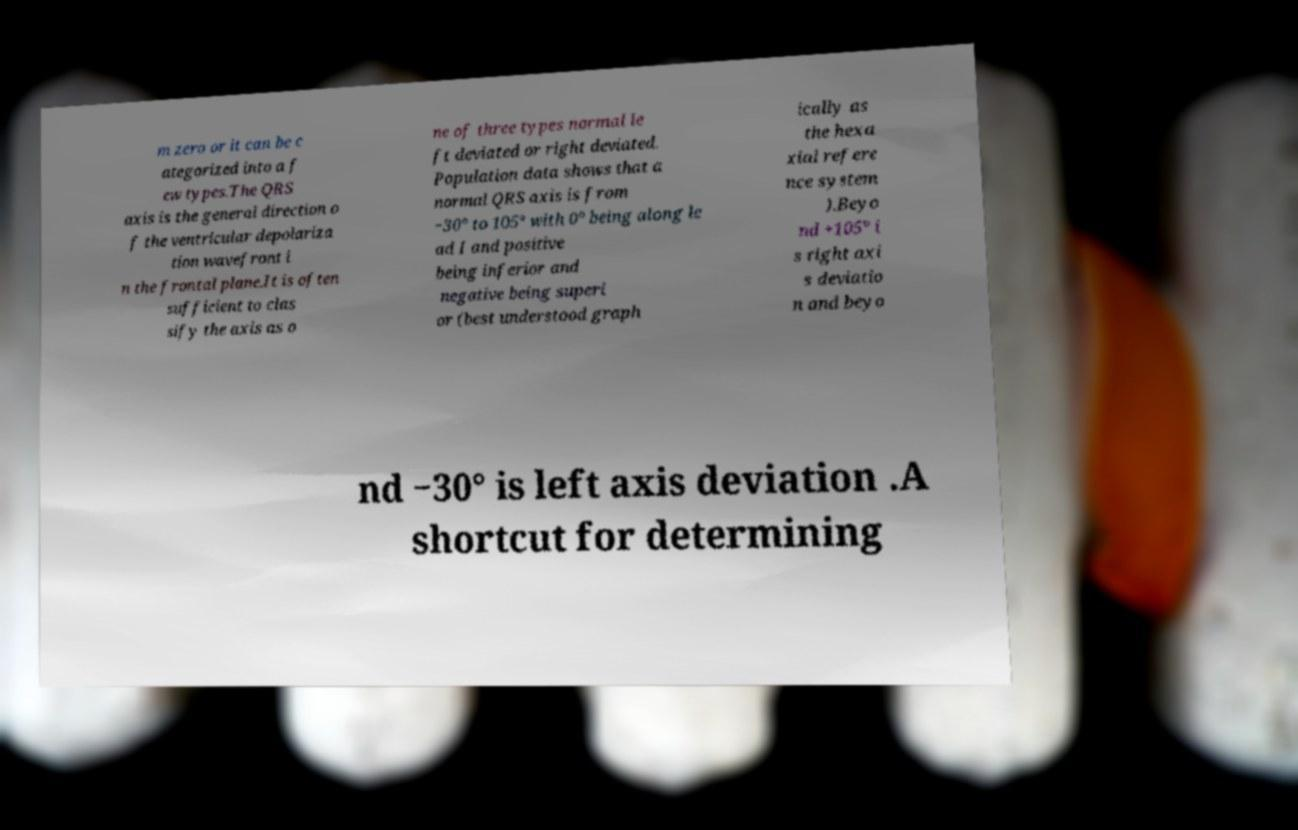For documentation purposes, I need the text within this image transcribed. Could you provide that? m zero or it can be c ategorized into a f ew types.The QRS axis is the general direction o f the ventricular depolariza tion wavefront i n the frontal plane.It is often sufficient to clas sify the axis as o ne of three types normal le ft deviated or right deviated. Population data shows that a normal QRS axis is from −30° to 105° with 0° being along le ad I and positive being inferior and negative being superi or (best understood graph ically as the hexa xial refere nce system ).Beyo nd +105° i s right axi s deviatio n and beyo nd −30° is left axis deviation .A shortcut for determining 